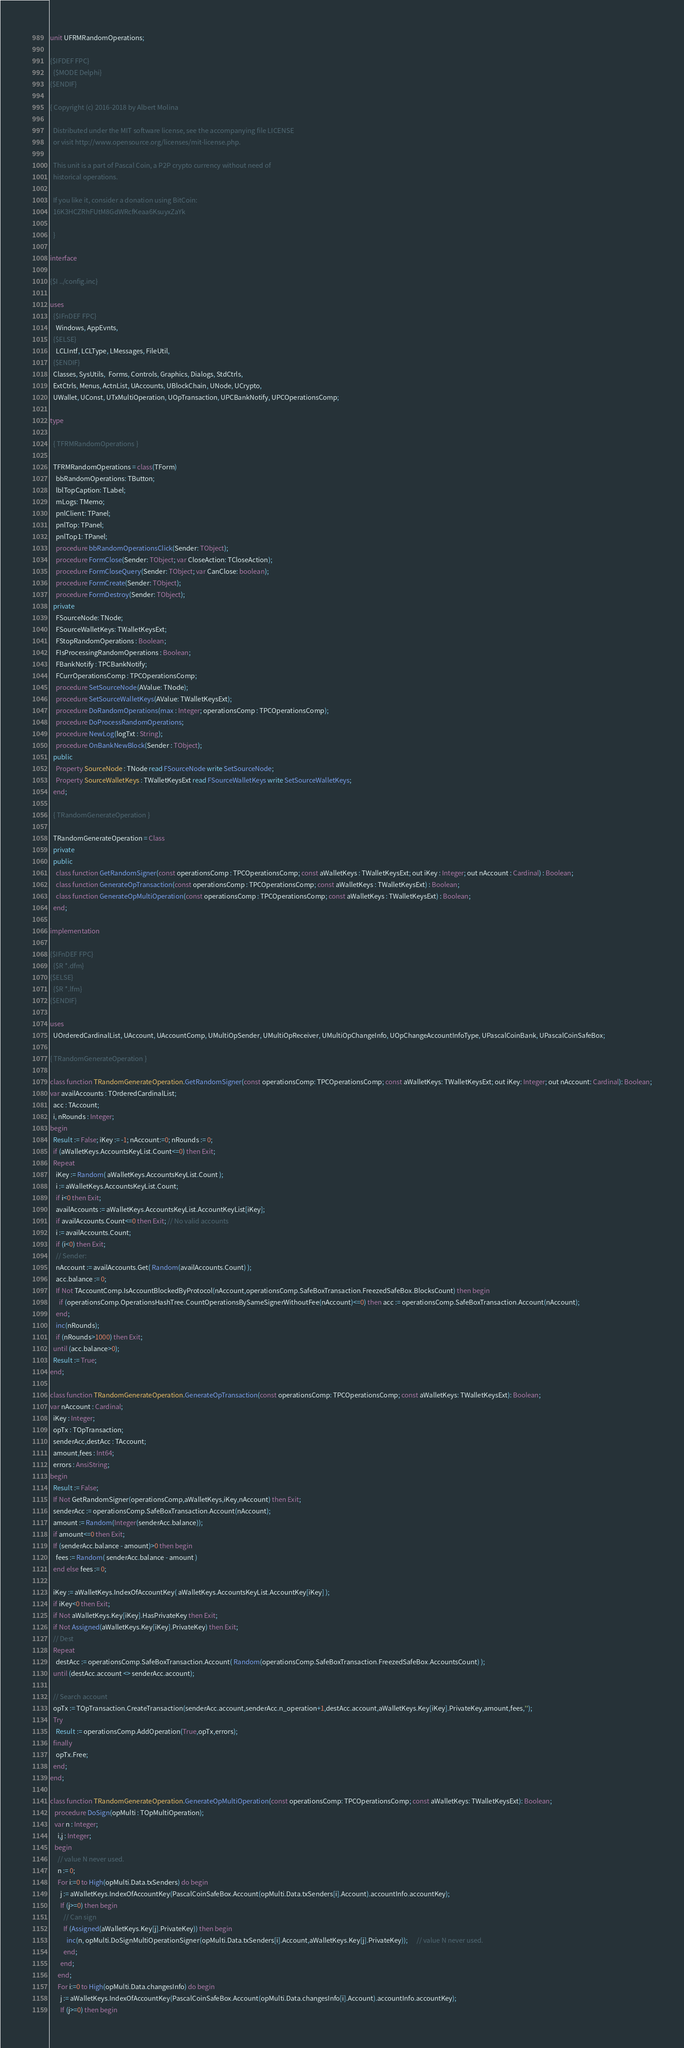Convert code to text. <code><loc_0><loc_0><loc_500><loc_500><_Pascal_>unit UFRMRandomOperations;

{$IFDEF FPC}
  {$MODE Delphi}
{$ENDIF}

{ Copyright (c) 2016-2018 by Albert Molina

  Distributed under the MIT software license, see the accompanying file LICENSE
  or visit http://www.opensource.org/licenses/mit-license.php.

  This unit is a part of Pascal Coin, a P2P crypto currency without need of
  historical operations.

  If you like it, consider a donation using BitCoin:
  16K3HCZRhFUtM8GdWRcfKeaa6KsuyxZaYk

  }

interface

{$I ../config.inc}

uses
  {$IFnDEF FPC}
    Windows, AppEvnts,
  {$ELSE}
    LCLIntf, LCLType, LMessages, FileUtil,
  {$ENDIF}
  Classes, SysUtils,  Forms, Controls, Graphics, Dialogs, StdCtrls,
  ExtCtrls, Menus, ActnList, UAccounts, UBlockChain, UNode, UCrypto,
  UWallet, UConst, UTxMultiOperation, UOpTransaction, UPCBankNotify, UPCOperationsComp;

type

  { TFRMRandomOperations }

  TFRMRandomOperations = class(TForm)
    bbRandomOperations: TButton;
    lblTopCaption: TLabel;
    mLogs: TMemo;
    pnlClient: TPanel;
    pnlTop: TPanel;
    pnlTop1: TPanel;
    procedure bbRandomOperationsClick(Sender: TObject);
    procedure FormClose(Sender: TObject; var CloseAction: TCloseAction);
    procedure FormCloseQuery(Sender: TObject; var CanClose: boolean);
    procedure FormCreate(Sender: TObject);
    procedure FormDestroy(Sender: TObject);
  private
    FSourceNode: TNode;
    FSourceWalletKeys: TWalletKeysExt;
    FStopRandomOperations : Boolean;
    FIsProcessingRandomOperations : Boolean;
    FBankNotify : TPCBankNotify;
    FCurrOperationsComp : TPCOperationsComp;
    procedure SetSourceNode(AValue: TNode);
    procedure SetSourceWalletKeys(AValue: TWalletKeysExt);
    procedure DoRandomOperations(max : Integer; operationsComp : TPCOperationsComp);
    procedure DoProcessRandomOperations;
    procedure NewLog(logTxt : String);
    procedure OnBankNewBlock(Sender : TObject);
  public
    Property SourceNode : TNode read FSourceNode write SetSourceNode;
    Property SourceWalletKeys : TWalletKeysExt read FSourceWalletKeys write SetSourceWalletKeys;
  end;

  { TRandomGenerateOperation }

  TRandomGenerateOperation = Class
  private
  public
    class function GetRandomSigner(const operationsComp : TPCOperationsComp; const aWalletKeys : TWalletKeysExt; out iKey : Integer; out nAccount : Cardinal) : Boolean;
    class function GenerateOpTransaction(const operationsComp : TPCOperationsComp; const aWalletKeys : TWalletKeysExt) : Boolean;
    class function GenerateOpMultiOperation(const operationsComp : TPCOperationsComp; const aWalletKeys : TWalletKeysExt) : Boolean;
  end;

implementation

{$IFnDEF FPC}
  {$R *.dfm}
{$ELSE}
  {$R *.lfm}
{$ENDIF}

uses
  UOrderedCardinalList, UAccount, UAccountComp, UMultiOpSender, UMultiOpReceiver, UMultiOpChangeInfo, UOpChangeAccountInfoType, UPascalCoinBank, UPascalCoinSafeBox;

{ TRandomGenerateOperation }

class function TRandomGenerateOperation.GetRandomSigner(const operationsComp: TPCOperationsComp; const aWalletKeys: TWalletKeysExt; out iKey: Integer; out nAccount: Cardinal): Boolean;
var availAccounts : TOrderedCardinalList;
  acc : TAccount;
  i, nRounds : Integer;
begin
  Result := False; iKey := -1; nAccount:=0; nRounds := 0;
  if (aWalletKeys.AccountsKeyList.Count<=0) then Exit;
  Repeat
    iKey := Random( aWalletKeys.AccountsKeyList.Count );
    i := aWalletKeys.AccountsKeyList.Count;
    if i<0 then Exit;
    availAccounts := aWalletKeys.AccountsKeyList.AccountKeyList[iKey];
    if availAccounts.Count<=0 then Exit; // No valid accounts
    i := availAccounts.Count;
    if (i<0) then Exit;
    // Sender:
    nAccount := availAccounts.Get( Random(availAccounts.Count) );
    acc.balance := 0;
    If Not TAccountComp.IsAccountBlockedByProtocol(nAccount,operationsComp.SafeBoxTransaction.FreezedSafeBox.BlocksCount) then begin
      if (operationsComp.OperationsHashTree.CountOperationsBySameSignerWithoutFee(nAccount)<=0) then acc := operationsComp.SafeBoxTransaction.Account(nAccount);
    end;
    inc(nRounds);
    if (nRounds>1000) then Exit;
  until (acc.balance>0);
  Result := True;
end;

class function TRandomGenerateOperation.GenerateOpTransaction(const operationsComp: TPCOperationsComp; const aWalletKeys: TWalletKeysExt): Boolean;
var nAccount : Cardinal;
  iKey : Integer;
  opTx : TOpTransaction;
  senderAcc,destAcc : TAccount;
  amount,fees : Int64;
  errors : AnsiString;
begin
  Result := False;
  If Not GetRandomSigner(operationsComp,aWalletKeys,iKey,nAccount) then Exit;
  senderAcc := operationsComp.SafeBoxTransaction.Account(nAccount);
  amount := Random(Integer(senderAcc.balance));
  if amount<=0 then Exit;
  If (senderAcc.balance - amount)>0 then begin
    fees := Random( senderAcc.balance - amount )
  end else fees := 0;

  iKey := aWalletKeys.IndexOfAccountKey( aWalletKeys.AccountsKeyList.AccountKey[iKey] );
  if iKey<0 then Exit;
  if Not aWalletKeys.Key[iKey].HasPrivateKey then Exit;
  if Not Assigned(aWalletKeys.Key[iKey].PrivateKey) then Exit;
  // Dest
  Repeat
    destAcc := operationsComp.SafeBoxTransaction.Account( Random(operationsComp.SafeBoxTransaction.FreezedSafeBox.AccountsCount) );
  until (destAcc.account <> senderAcc.account);

  // Search account
  opTx := TOpTransaction.CreateTransaction(senderAcc.account,senderAcc.n_operation+1,destAcc.account,aWalletKeys.Key[iKey].PrivateKey,amount,fees,'');
  Try
    Result := operationsComp.AddOperation(True,opTx,errors);
  finally
    opTx.Free;
  end;
end;

class function TRandomGenerateOperation.GenerateOpMultiOperation(const operationsComp: TPCOperationsComp; const aWalletKeys: TWalletKeysExt): Boolean;
   procedure DoSign(opMulti : TOpMultiOperation);
   var n : Integer;
     i,j : Integer;
   begin
     // value N never used.
     n := 0;
     For i:=0 to High(opMulti.Data.txSenders) do begin
       j := aWalletKeys.IndexOfAccountKey(PascalCoinSafeBox.Account(opMulti.Data.txSenders[i].Account).accountInfo.accountKey);
       If (j>=0) then begin
         // Can sign
         If (Assigned(aWalletKeys.Key[j].PrivateKey)) then begin
           inc(n, opMulti.DoSignMultiOperationSigner(opMulti.Data.txSenders[i].Account,aWalletKeys.Key[j].PrivateKey));      // value N never used.
         end;
       end;
     end;
     For i:=0 to High(opMulti.Data.changesInfo) do begin
       j := aWalletKeys.IndexOfAccountKey(PascalCoinSafeBox.Account(opMulti.Data.changesInfo[i].Account).accountInfo.accountKey);
       If (j>=0) then begin</code> 